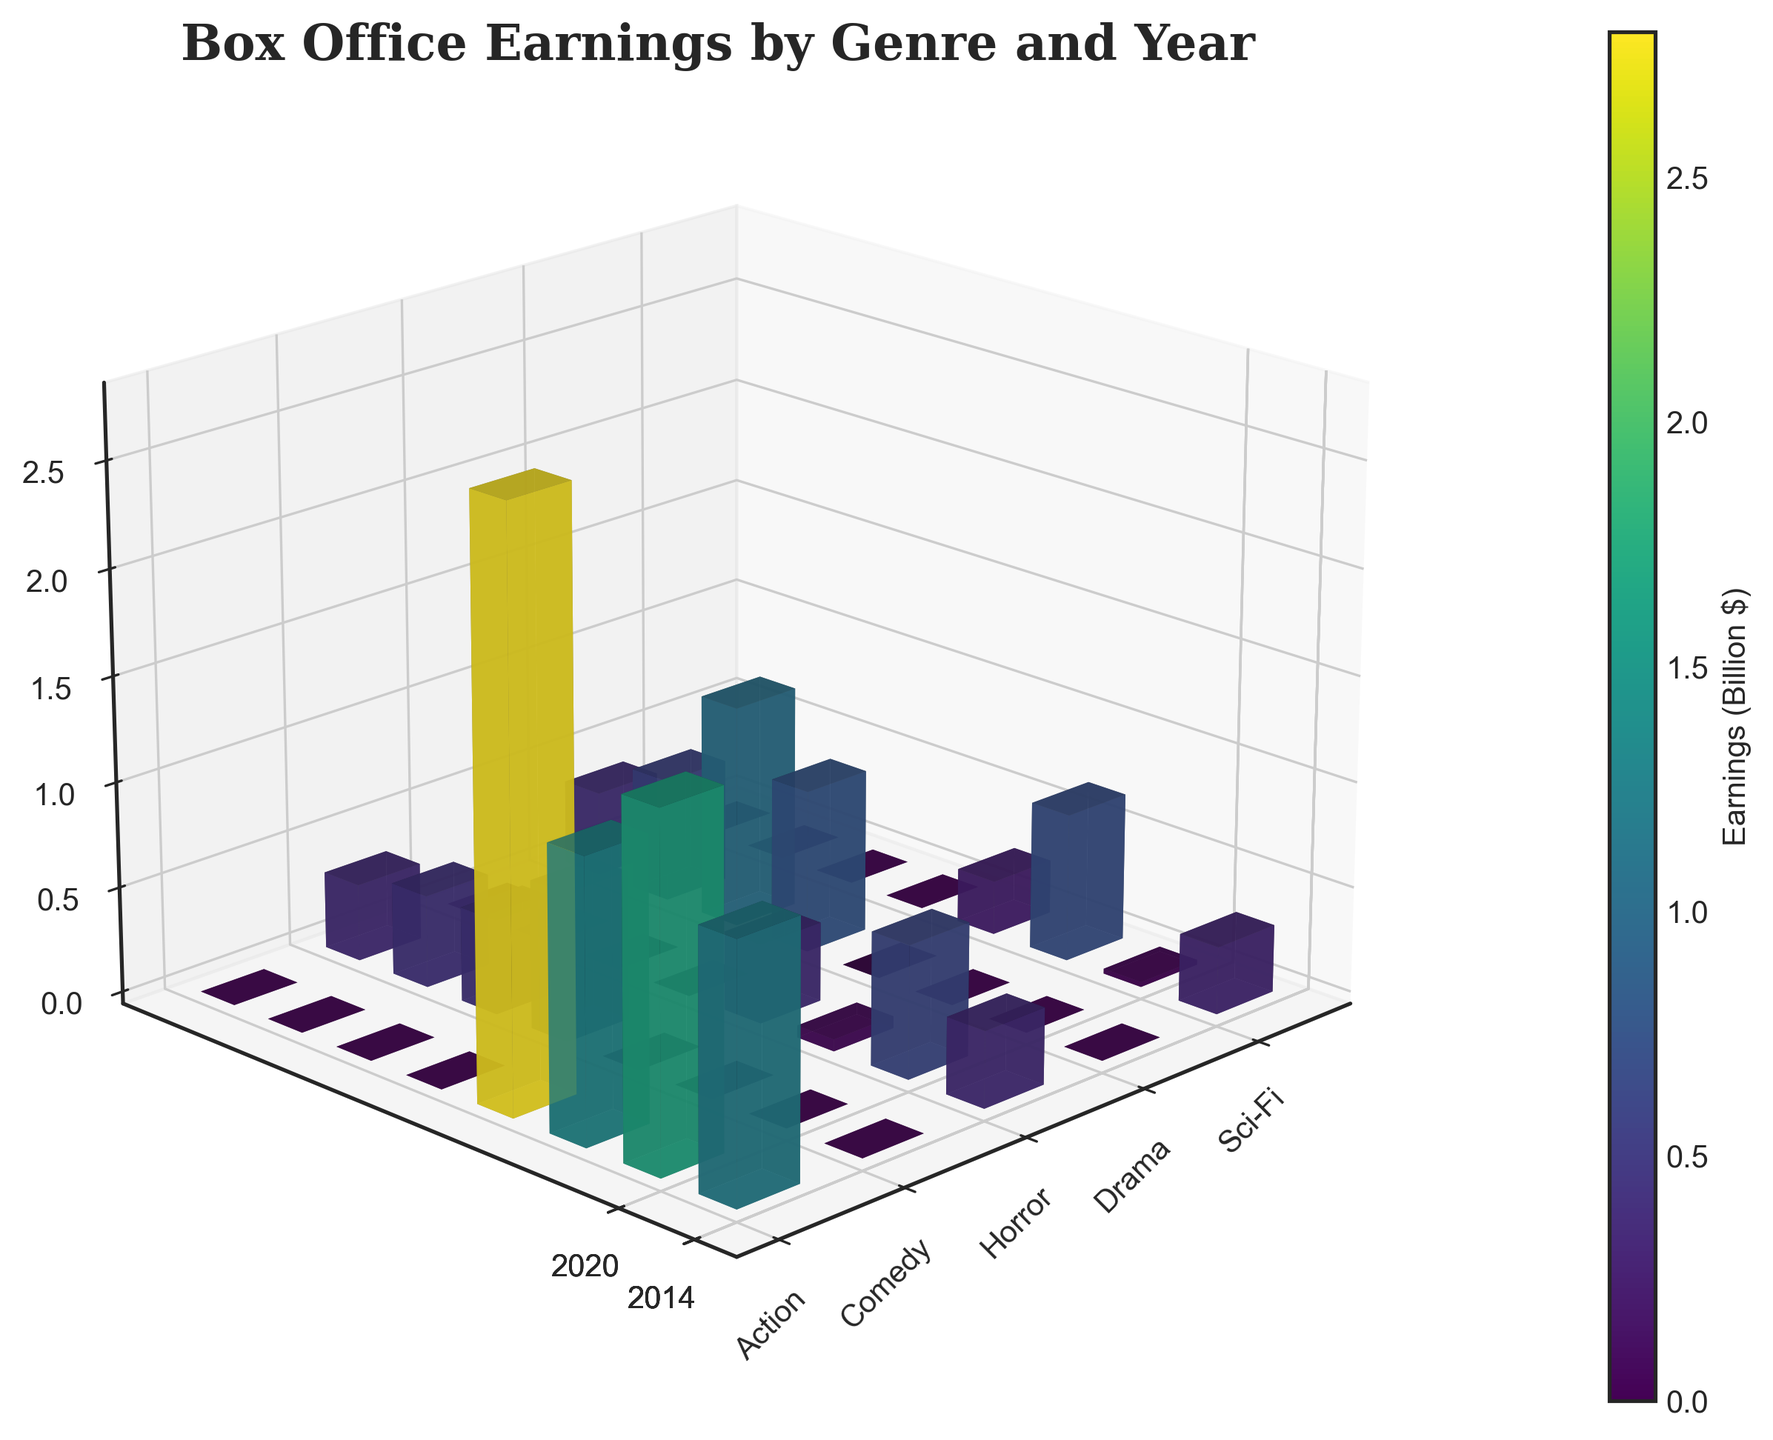What is the title of the figure? The title is usually located at the top of the figure. The rendered plot's title is "Box Office Earnings by Genre and Year".
Answer: Box Office Earnings by Genre and Year Which years are represented on the y-axis? The y-axis typically contains the tick labels that represent different years. The labels on the y-axis are 2013, 2014, 2015, 2016, 2017, 2018, 2019, and 2020.
Answer: 2013, 2014, 2015, 2016, 2017, 2018, 2019, 2020 Which genre has the highest bar in the entire plot? To determine this, we need to observe which bar reaches the maximum height. The highest bar corresponds to the "Action" genre in the year 2019.
Answer: Action What are the earnings for the "Drama" genre in the year 2014? Locate the bar corresponding to the "Drama" genre on the x-axis and the year 2014 on the y-axis. The bar height indicates the earnings, which are normalized to billions. The height for 2014 "Drama" is approximately 0.70 billion dollars.
Answer: 0.70 billion dollars Compare the earnings of the "Horror" genre in 2013 and 2015. Which year had higher earnings? Identify the two bars corresponding to the "Horror" genre for 2013 and 2015. The height of the 2013 bar is greater than that of the 2015 bar.
Answer: 2013 Which year had the highest aggregate earnings for the "Comedy" genre in the past decade? Sum the heights of all bars in the "Comedy" genre for each year and find the year with the highest sum. In 2015, the height is approximately 0.63 billion dollars, which is the highest.
Answer: 2015 How does the "Sci-Fi" genre earnings in 2014 compare to 2018? Compare the heights of the "Sci-Fi" bars for 2014 and 2018. The 2014 bar is taller than the 2018 bar, indicating higher earnings in 2014.
Answer: 2014 Which genre and year combination has the shortest bar? Find the combination with the smallest bar height. The shortest bar is "Horror" in 2015.
Answer: Horror, 2015 What is the elevation and azimuth angle of the plot's viewing angle? These angles are mentioned in the code but are visually evident in the 3D perspective of the plot. The elevation is 20, and the azimuth is 225.
Answer: Elevation 20, Azimuth 225 